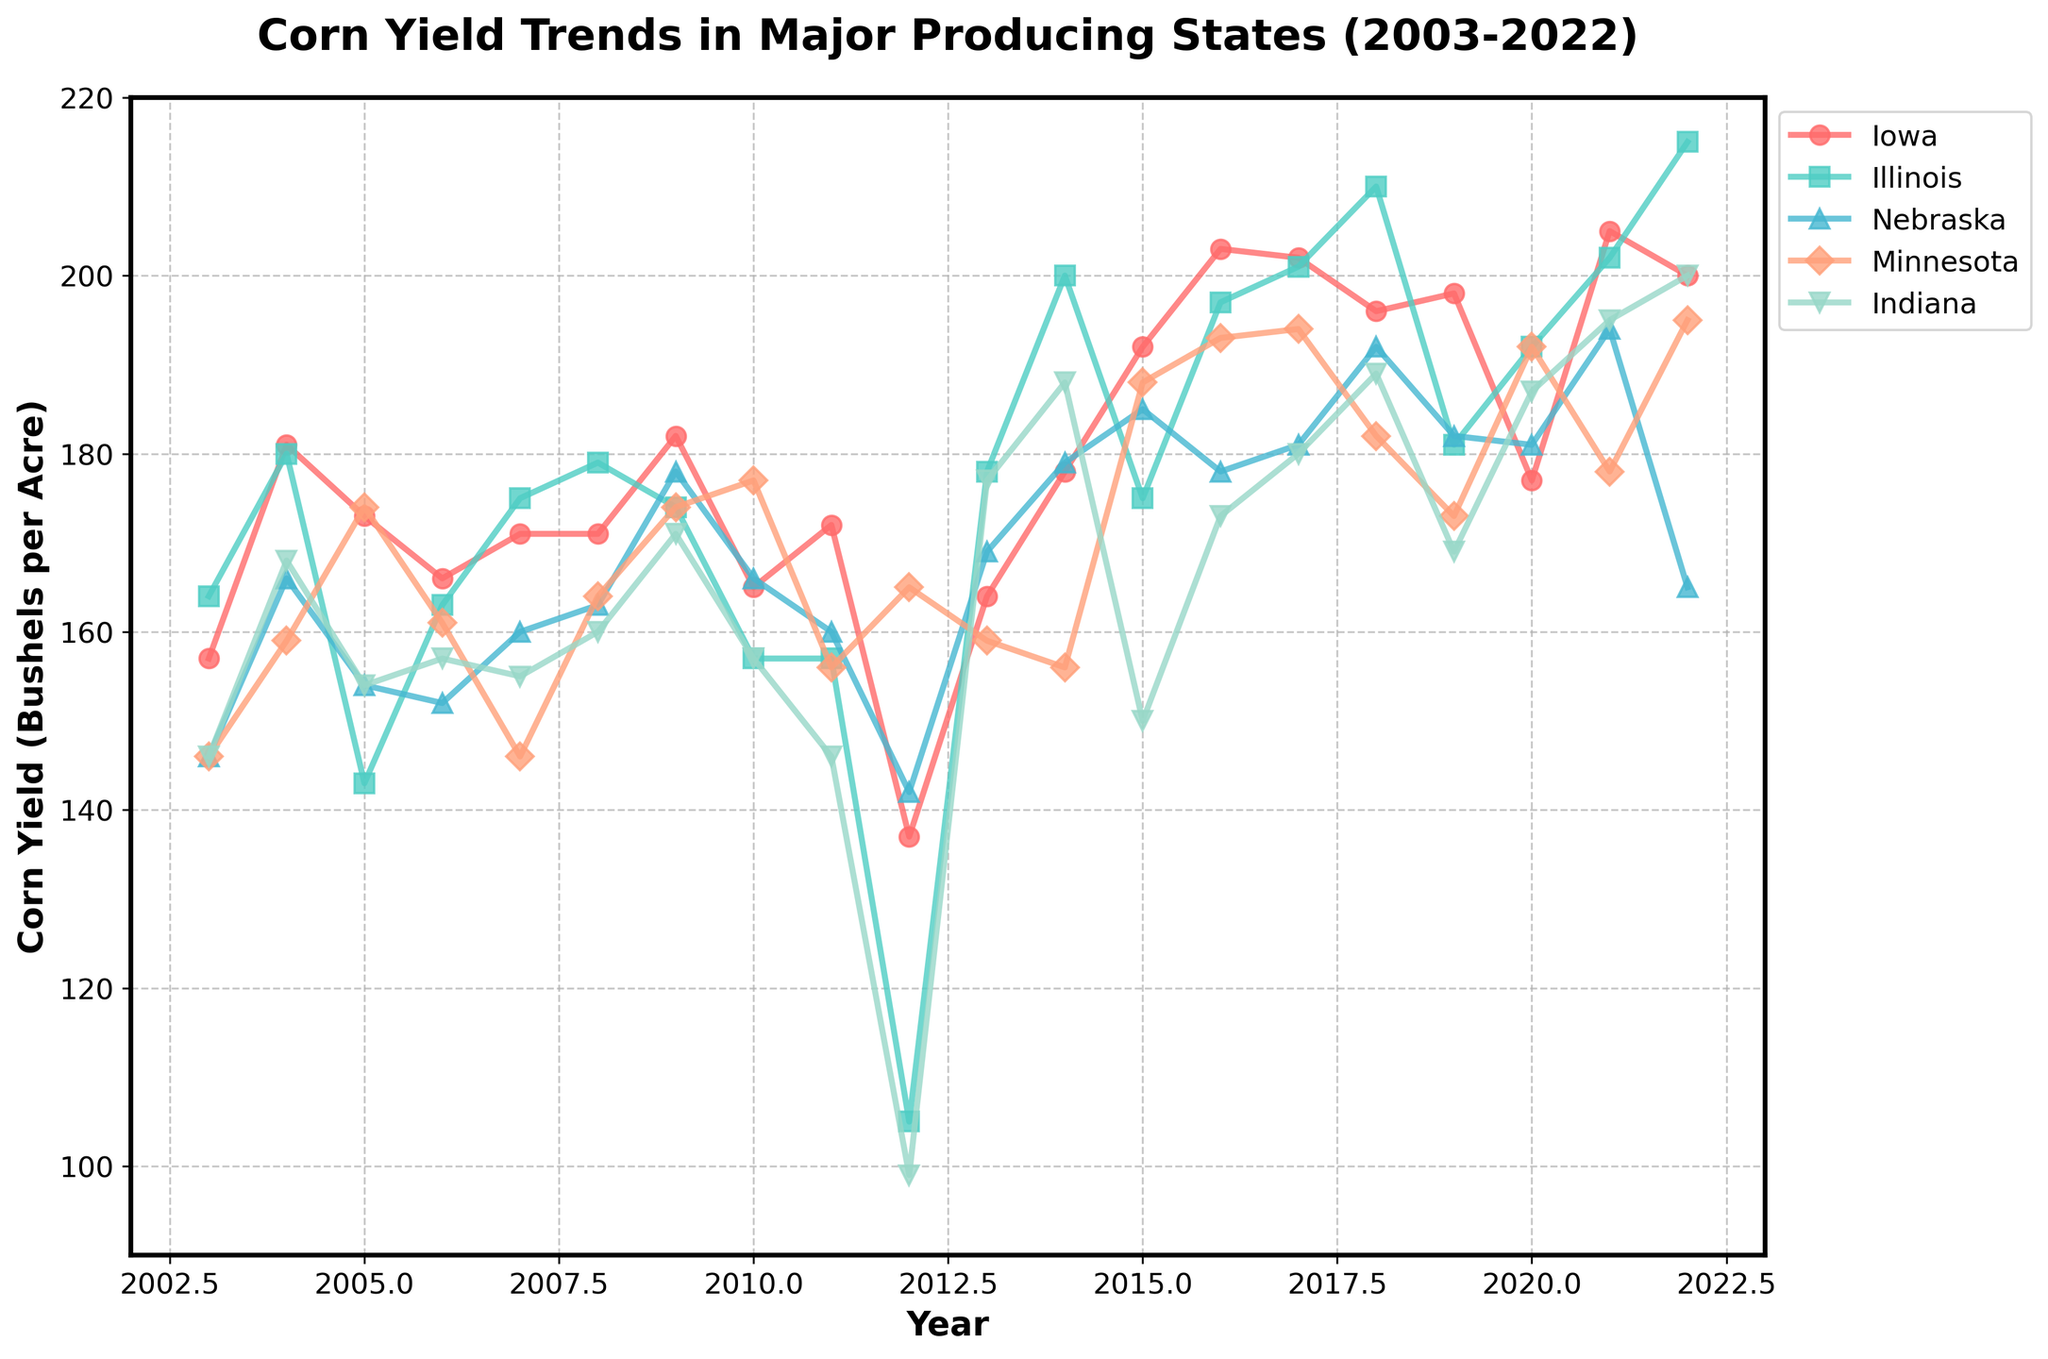What is the trend of corn yield in Iowa over the past 20 years? The plot shows a general increasing trend in corn yield for Iowa. The yield starts around 157 bushels per acre in 2003 and increases to about 200-205 bushels per acre by 2022, despite some fluctuations in between.
Answer: Increasing trend Which state had the lowest corn yield in 2012 and what was it? In 2012, the plot shows that Indiana had the lowest corn yield among the listed states. The yield for Indiana was around 99 bushels per acre.
Answer: Indiana, 99 bushels per acre Compare the corn yield in Illinois and Nebraska in 2018. Which state had a higher yield and by how much? In 2018, the corn yield for Illinois was around 210 bushels per acre and for Nebraska, it was about 192 bushels per acre. So, Illinois had a higher yield by 210 - 192 = 18 bushels per acre.
Answer: Illinois, 18 bushels per acre What is the average corn yield for Minnesota between 2015 and 2020? The yields for Minnesota from 2015 to 2020 are 188, 193, 194, 182, 173, and 192 respectively. The sum of these yields is 1122. The average is 1122 / 6 ≈ 187 bushels per acre.
Answer: 187 bushels per acre Which year recorded the highest corn yield in Illinois, and what was the yield? The plot shows that the highest corn yield in Illinois was recorded in 2022, with a yield of around 215 bushels per acre.
Answer: 2022, 215 bushels per acre By how much did the corn yield in Nebraska increase from 2003 to 2009? In 2003, the yield in Nebraska was around 146 bushels per acre and in 2009 it was approximately 178 bushels per acre. The increase is 178 - 146 = 32 bushels per acre.
Answer: 32 bushels per acre Which state had the most consistent yield trend with the least fluctuations over the years? The plot shows that Illinois had relatively consistent yield trends without sharp fluctuations, compared to other states like Indiana or Nebraska which show more variability.
Answer: Illinois What is the difference in corn yield between the highest and lowest yielding states in 2022? In 2022, Illinois had the highest yield at 215 bushels per acre, and Nebraska had the lowest at 165 bushels per acre. The difference is 215 - 165 = 50 bushels per acre.
Answer: 50 bushels per acre 